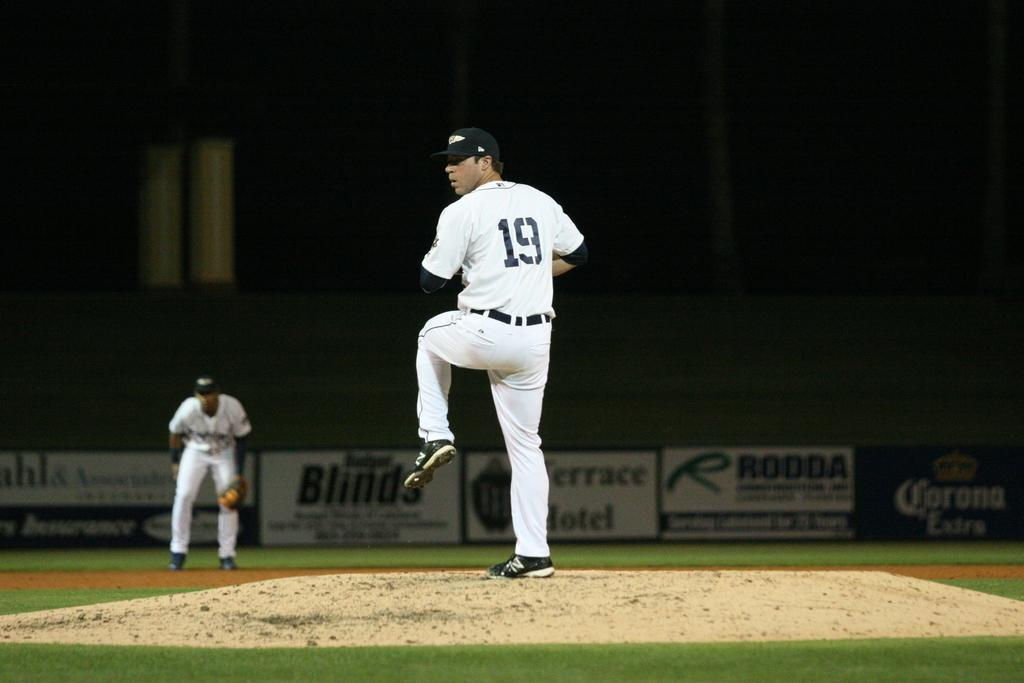Provide a one-sentence caption for the provided image. A baseball pitcher with the number 19 sewn into his jersey preparing to throw a ball. 